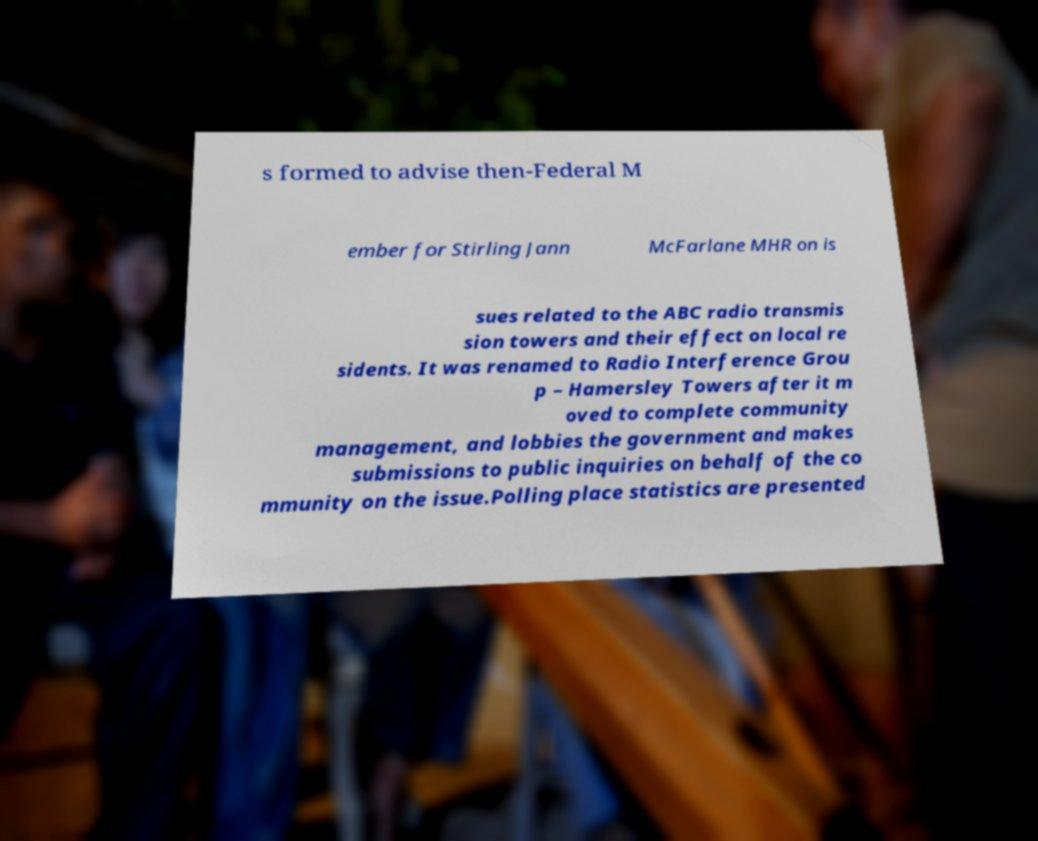Please read and relay the text visible in this image. What does it say? s formed to advise then-Federal M ember for Stirling Jann McFarlane MHR on is sues related to the ABC radio transmis sion towers and their effect on local re sidents. It was renamed to Radio Interference Grou p – Hamersley Towers after it m oved to complete community management, and lobbies the government and makes submissions to public inquiries on behalf of the co mmunity on the issue.Polling place statistics are presented 